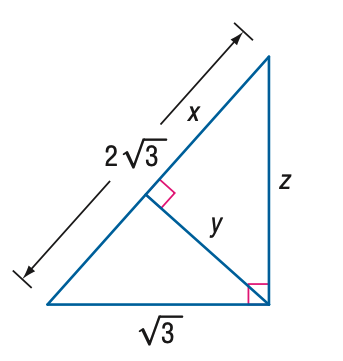Answer the mathemtical geometry problem and directly provide the correct option letter.
Question: Find y.
Choices: A: \frac { 3 } { 2 } B: 2 C: \frac { 3 } { 2 } \sqrt { 3 } D: 2 \sqrt { 3 } A 